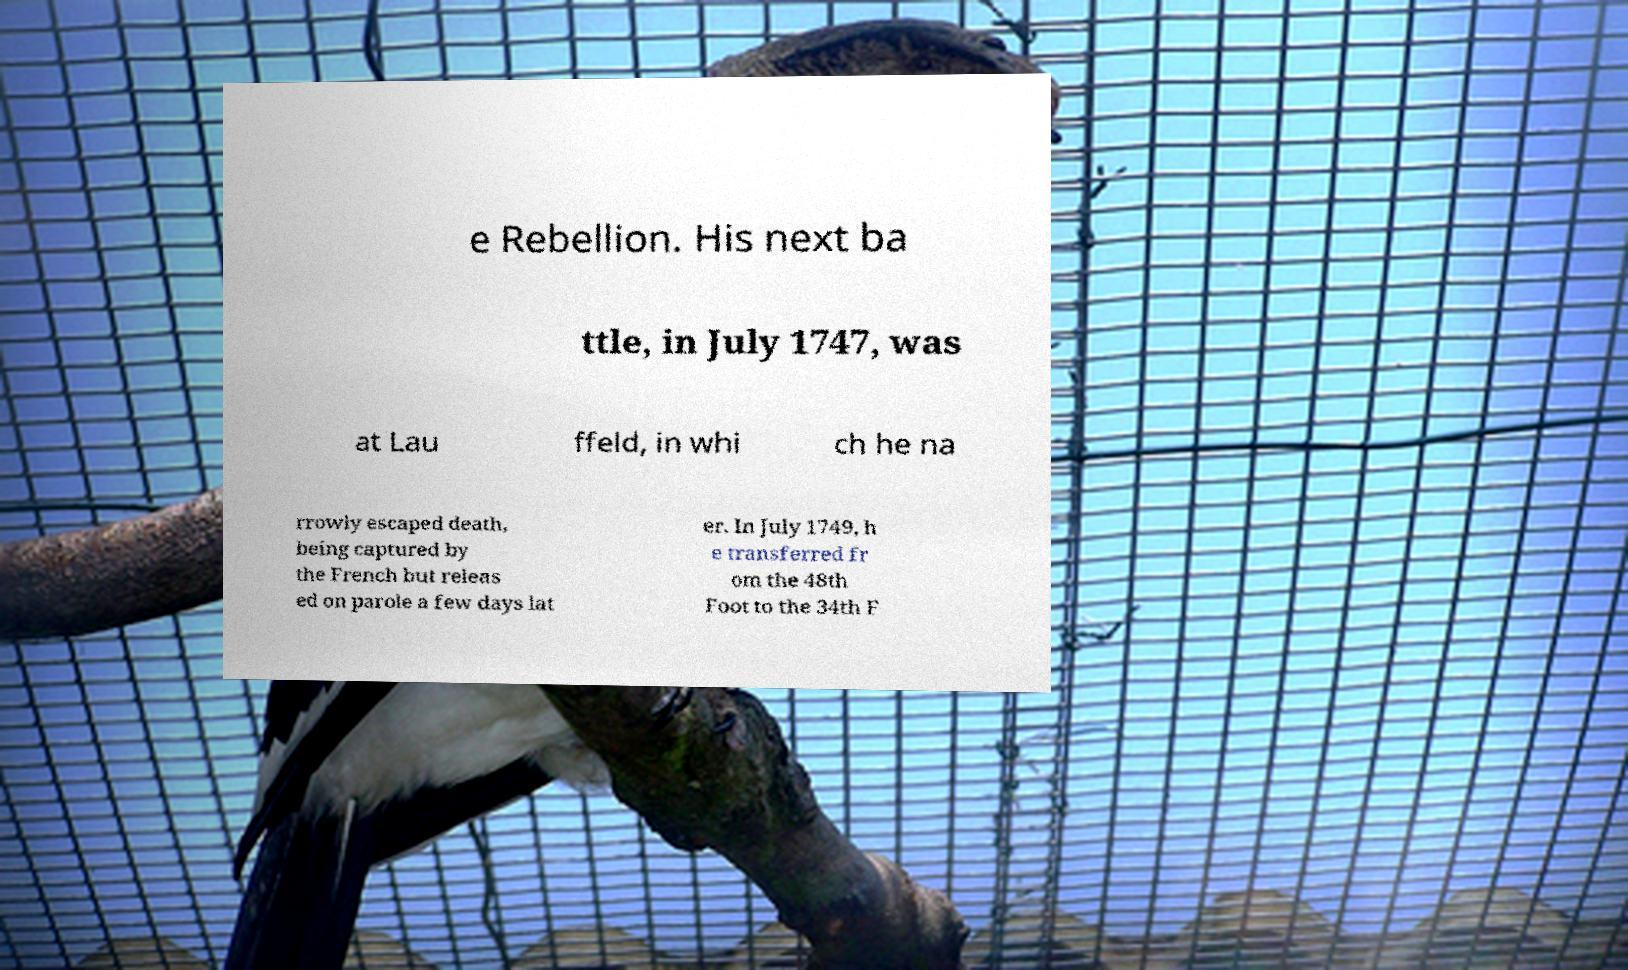There's text embedded in this image that I need extracted. Can you transcribe it verbatim? e Rebellion. His next ba ttle, in July 1747, was at Lau ffeld, in whi ch he na rrowly escaped death, being captured by the French but releas ed on parole a few days lat er. In July 1749, h e transferred fr om the 48th Foot to the 34th F 